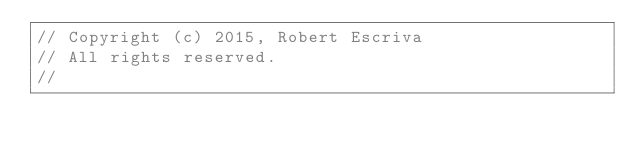<code> <loc_0><loc_0><loc_500><loc_500><_C_>// Copyright (c) 2015, Robert Escriva
// All rights reserved.
//</code> 